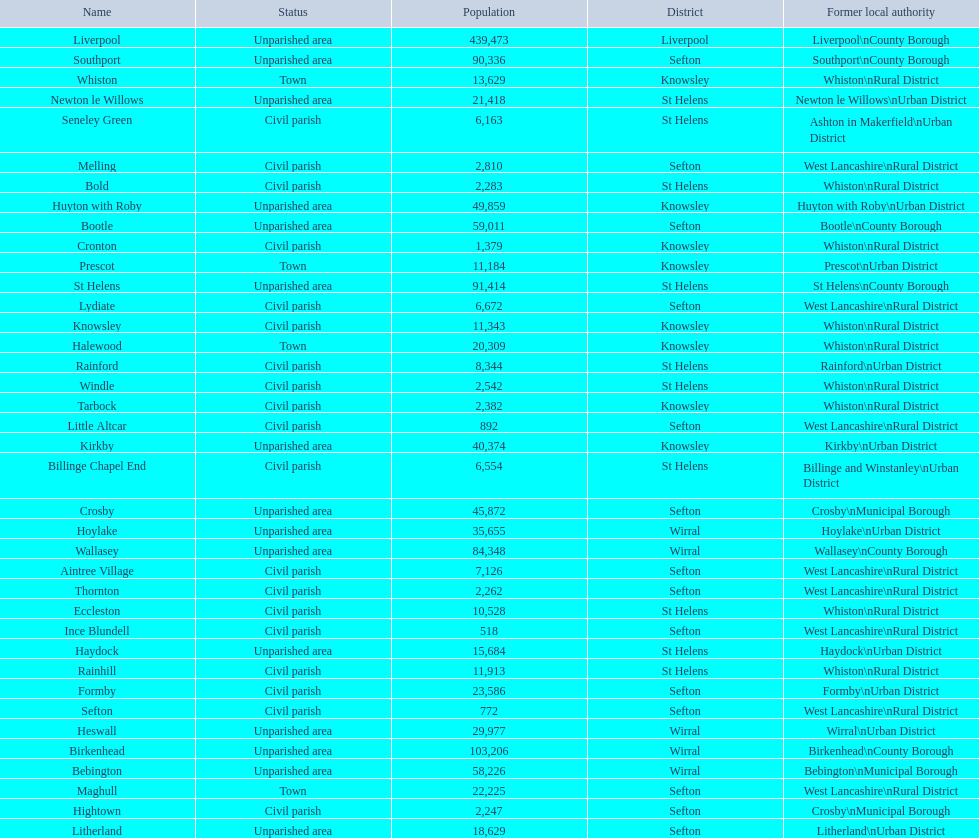How many inhabitants are there in formby? 23,586. Could you help me parse every detail presented in this table? {'header': ['Name', 'Status', 'Population', 'District', 'Former local authority'], 'rows': [['Liverpool', 'Unparished area', '439,473', 'Liverpool', 'Liverpool\\nCounty Borough'], ['Southport', 'Unparished area', '90,336', 'Sefton', 'Southport\\nCounty Borough'], ['Whiston', 'Town', '13,629', 'Knowsley', 'Whiston\\nRural District'], ['Newton le Willows', 'Unparished area', '21,418', 'St Helens', 'Newton le Willows\\nUrban District'], ['Seneley Green', 'Civil parish', '6,163', 'St Helens', 'Ashton in Makerfield\\nUrban District'], ['Melling', 'Civil parish', '2,810', 'Sefton', 'West Lancashire\\nRural District'], ['Bold', 'Civil parish', '2,283', 'St Helens', 'Whiston\\nRural District'], ['Huyton with Roby', 'Unparished area', '49,859', 'Knowsley', 'Huyton with Roby\\nUrban District'], ['Bootle', 'Unparished area', '59,011', 'Sefton', 'Bootle\\nCounty Borough'], ['Cronton', 'Civil parish', '1,379', 'Knowsley', 'Whiston\\nRural District'], ['Prescot', 'Town', '11,184', 'Knowsley', 'Prescot\\nUrban District'], ['St Helens', 'Unparished area', '91,414', 'St Helens', 'St Helens\\nCounty Borough'], ['Lydiate', 'Civil parish', '6,672', 'Sefton', 'West Lancashire\\nRural District'], ['Knowsley', 'Civil parish', '11,343', 'Knowsley', 'Whiston\\nRural District'], ['Halewood', 'Town', '20,309', 'Knowsley', 'Whiston\\nRural District'], ['Rainford', 'Civil parish', '8,344', 'St Helens', 'Rainford\\nUrban District'], ['Windle', 'Civil parish', '2,542', 'St Helens', 'Whiston\\nRural District'], ['Tarbock', 'Civil parish', '2,382', 'Knowsley', 'Whiston\\nRural District'], ['Little Altcar', 'Civil parish', '892', 'Sefton', 'West Lancashire\\nRural District'], ['Kirkby', 'Unparished area', '40,374', 'Knowsley', 'Kirkby\\nUrban District'], ['Billinge Chapel End', 'Civil parish', '6,554', 'St Helens', 'Billinge and Winstanley\\nUrban District'], ['Crosby', 'Unparished area', '45,872', 'Sefton', 'Crosby\\nMunicipal Borough'], ['Hoylake', 'Unparished area', '35,655', 'Wirral', 'Hoylake\\nUrban District'], ['Wallasey', 'Unparished area', '84,348', 'Wirral', 'Wallasey\\nCounty Borough'], ['Aintree Village', 'Civil parish', '7,126', 'Sefton', 'West Lancashire\\nRural District'], ['Thornton', 'Civil parish', '2,262', 'Sefton', 'West Lancashire\\nRural District'], ['Eccleston', 'Civil parish', '10,528', 'St Helens', 'Whiston\\nRural District'], ['Ince Blundell', 'Civil parish', '518', 'Sefton', 'West Lancashire\\nRural District'], ['Haydock', 'Unparished area', '15,684', 'St Helens', 'Haydock\\nUrban District'], ['Rainhill', 'Civil parish', '11,913', 'St Helens', 'Whiston\\nRural District'], ['Formby', 'Civil parish', '23,586', 'Sefton', 'Formby\\nUrban District'], ['Sefton', 'Civil parish', '772', 'Sefton', 'West Lancashire\\nRural District'], ['Heswall', 'Unparished area', '29,977', 'Wirral', 'Wirral\\nUrban District'], ['Birkenhead', 'Unparished area', '103,206', 'Wirral', 'Birkenhead\\nCounty Borough'], ['Bebington', 'Unparished area', '58,226', 'Wirral', 'Bebington\\nMunicipal Borough'], ['Maghull', 'Town', '22,225', 'Sefton', 'West Lancashire\\nRural District'], ['Hightown', 'Civil parish', '2,247', 'Sefton', 'Crosby\\nMunicipal Borough'], ['Litherland', 'Unparished area', '18,629', 'Sefton', 'Litherland\\nUrban District']]} 